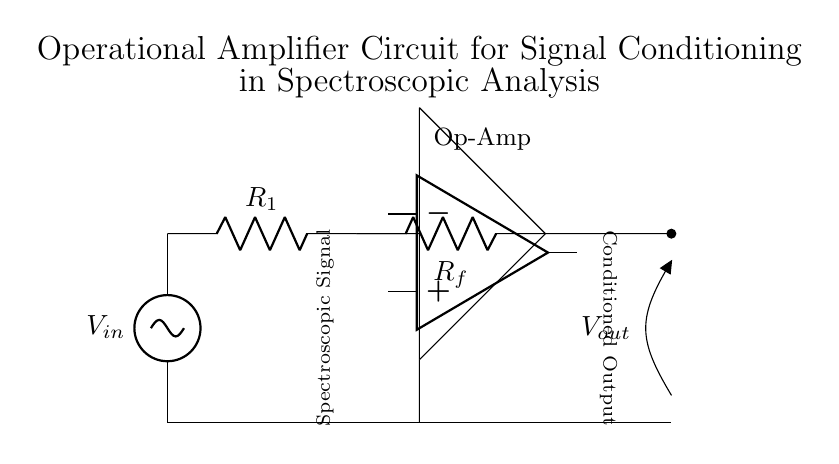What is the value of R1 in the circuit? R1 is labeled in the diagram, and it represents a resistor component that is directly connected to the input voltage source.
Answer: R1 What type of amplifier is used in this circuit? The diagram explicitly shows an operational amplifier symbol, indicating the type of amplifier used for signal conditioning in this circuit.
Answer: Operational amplifier What is the purpose of the resistor Rf in this circuit? Rf is part of the feedback network that connects the output of the operational amplifier back to its inverting input, which is crucial for determining the gain of the amplifier and stabilizing the feedback.
Answer: Feedback resistor What does Vout represent in the diagram? Vout is the output voltage that is generated from the signal conditioning process, shown at the output terminal of the circuit where it is marked with a label.
Answer: Output voltage How is the input signal connected to the circuit? The input signal is connected through a voltage source which is labeled V_in in the diagram, forming the initial point of signal entry into the operational amplifier circuit.
Answer: Through voltage source What role does the operational amplifier play in spectroscopic analysis? The operational amplifier amplifies weak signals from spectroscopic sources, which improves the signal-to-noise ratio and allows for better analysis of the spectroscopic data.
Answer: Amplification of signals What connection does R1 have with the operational amplifier? R1 is connected to the input of the operational amplifier, providing the input voltage which is then processed by the amplifier for signal conditioning.
Answer: Input connection 